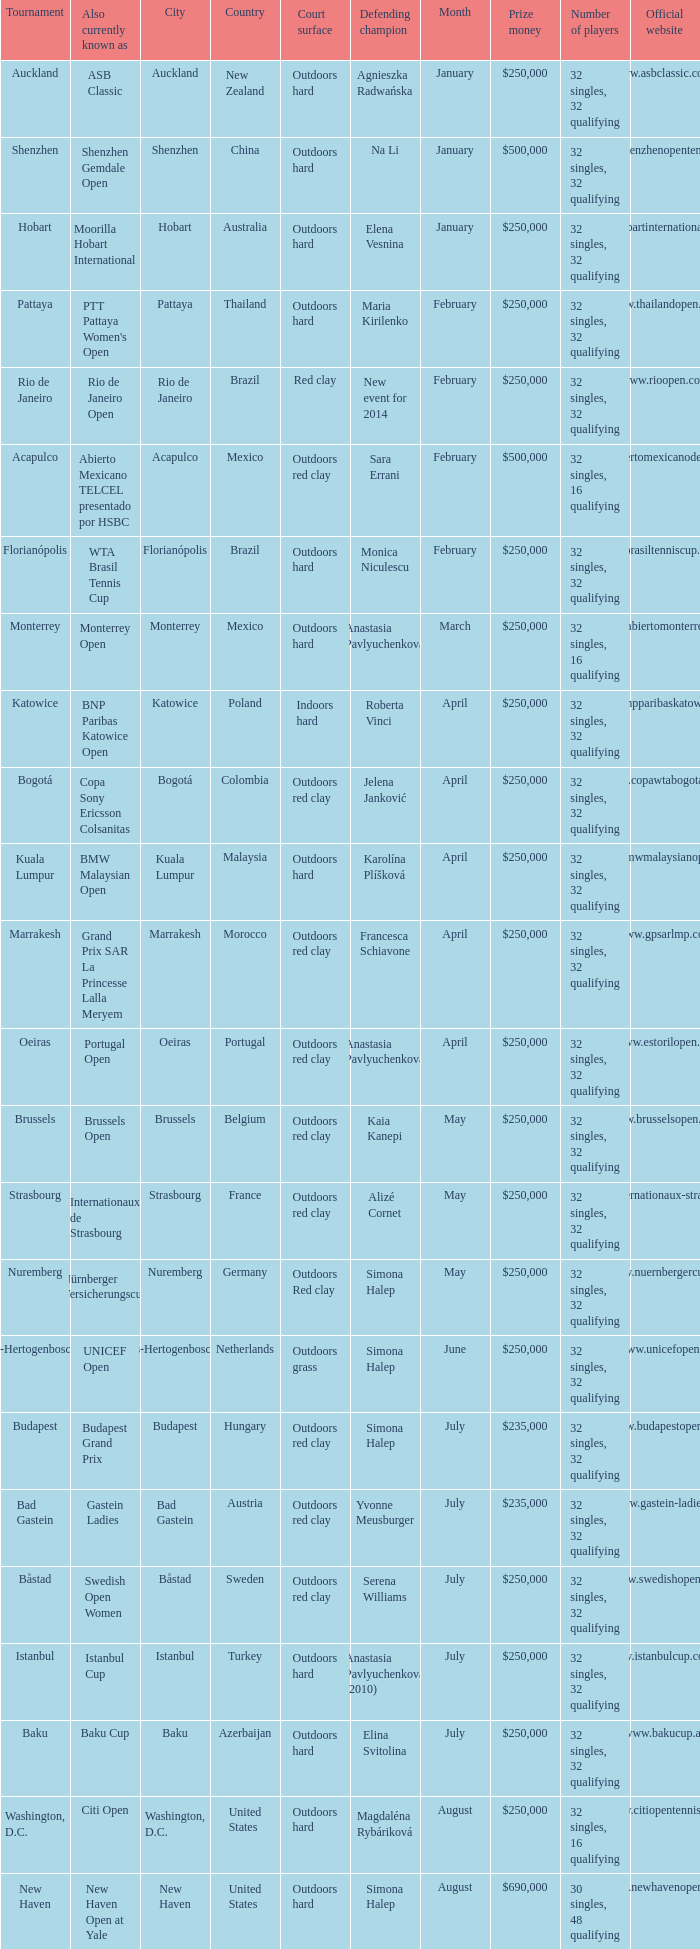What tournament is in katowice? Katowice. 